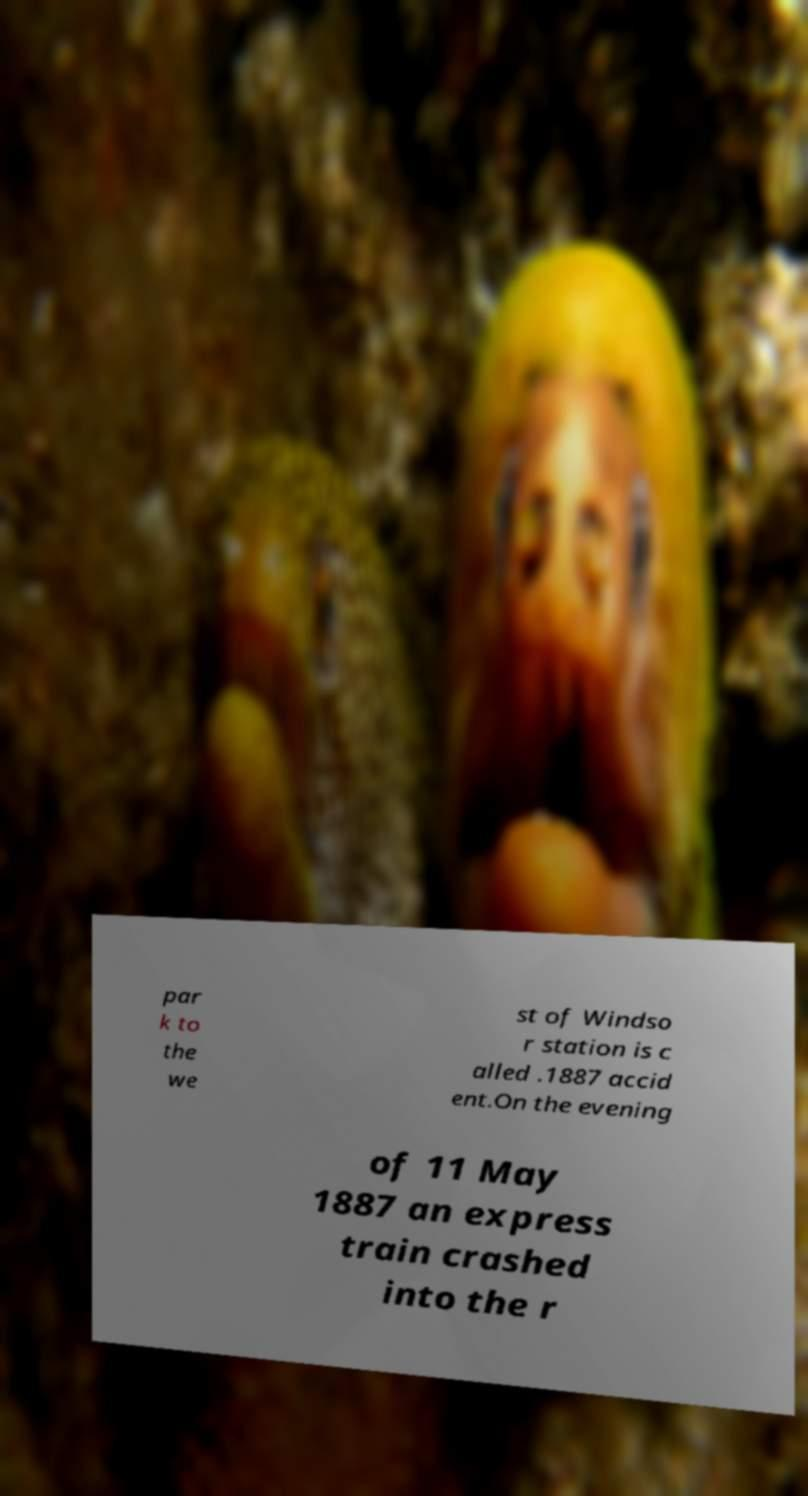Could you assist in decoding the text presented in this image and type it out clearly? par k to the we st of Windso r station is c alled .1887 accid ent.On the evening of 11 May 1887 an express train crashed into the r 